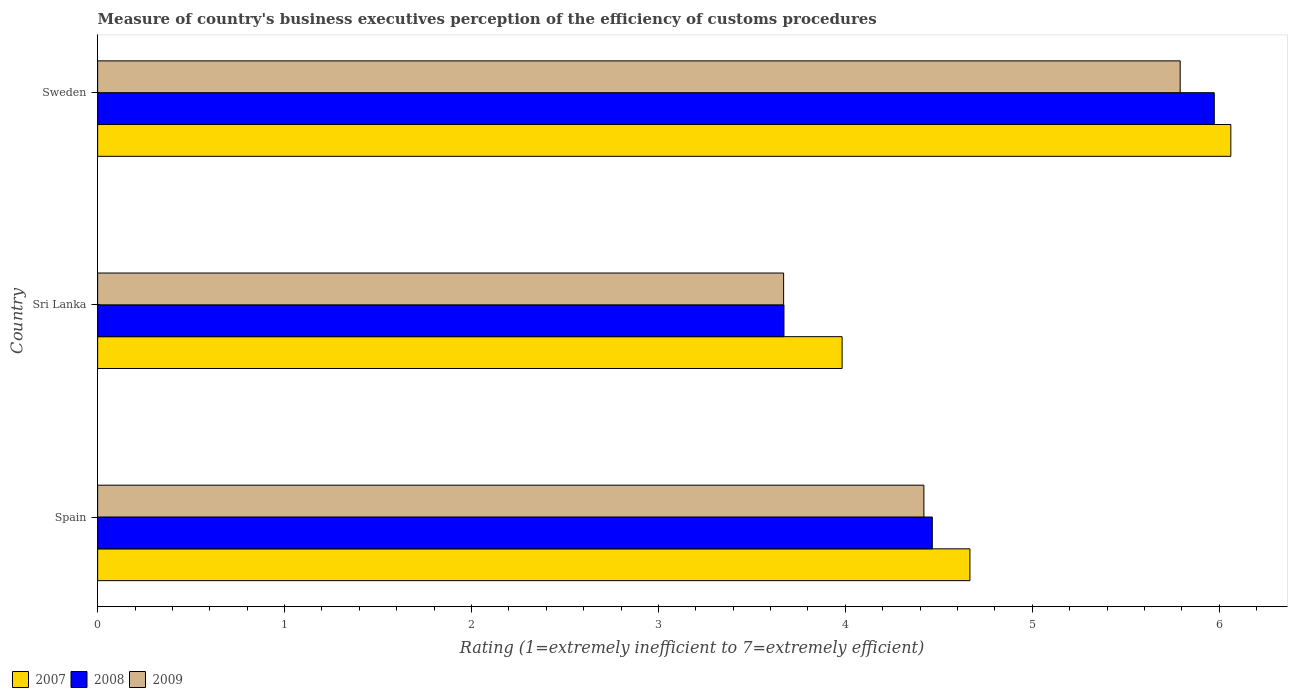Are the number of bars per tick equal to the number of legend labels?
Keep it short and to the point. Yes. Are the number of bars on each tick of the Y-axis equal?
Your answer should be compact. Yes. What is the label of the 3rd group of bars from the top?
Offer a very short reply. Spain. In how many cases, is the number of bars for a given country not equal to the number of legend labels?
Give a very brief answer. 0. What is the rating of the efficiency of customs procedure in 2008 in Spain?
Ensure brevity in your answer.  4.47. Across all countries, what is the maximum rating of the efficiency of customs procedure in 2007?
Give a very brief answer. 6.06. Across all countries, what is the minimum rating of the efficiency of customs procedure in 2008?
Keep it short and to the point. 3.67. In which country was the rating of the efficiency of customs procedure in 2007 minimum?
Ensure brevity in your answer.  Sri Lanka. What is the total rating of the efficiency of customs procedure in 2007 in the graph?
Give a very brief answer. 14.71. What is the difference between the rating of the efficiency of customs procedure in 2009 in Spain and that in Sri Lanka?
Provide a succinct answer. 0.75. What is the difference between the rating of the efficiency of customs procedure in 2008 in Spain and the rating of the efficiency of customs procedure in 2009 in Sweden?
Your response must be concise. -1.33. What is the average rating of the efficiency of customs procedure in 2009 per country?
Give a very brief answer. 4.63. What is the difference between the rating of the efficiency of customs procedure in 2007 and rating of the efficiency of customs procedure in 2008 in Sri Lanka?
Provide a succinct answer. 0.31. In how many countries, is the rating of the efficiency of customs procedure in 2009 greater than 0.8 ?
Your response must be concise. 3. What is the ratio of the rating of the efficiency of customs procedure in 2008 in Spain to that in Sweden?
Ensure brevity in your answer.  0.75. Is the rating of the efficiency of customs procedure in 2007 in Spain less than that in Sweden?
Keep it short and to the point. Yes. Is the difference between the rating of the efficiency of customs procedure in 2007 in Spain and Sweden greater than the difference between the rating of the efficiency of customs procedure in 2008 in Spain and Sweden?
Make the answer very short. Yes. What is the difference between the highest and the second highest rating of the efficiency of customs procedure in 2007?
Your answer should be very brief. 1.4. What is the difference between the highest and the lowest rating of the efficiency of customs procedure in 2007?
Provide a succinct answer. 2.08. In how many countries, is the rating of the efficiency of customs procedure in 2007 greater than the average rating of the efficiency of customs procedure in 2007 taken over all countries?
Provide a short and direct response. 1. Is the sum of the rating of the efficiency of customs procedure in 2007 in Spain and Sri Lanka greater than the maximum rating of the efficiency of customs procedure in 2008 across all countries?
Your answer should be very brief. Yes. How many countries are there in the graph?
Your answer should be compact. 3. Are the values on the major ticks of X-axis written in scientific E-notation?
Your response must be concise. No. Does the graph contain any zero values?
Your answer should be compact. No. Does the graph contain grids?
Your answer should be compact. No. Where does the legend appear in the graph?
Give a very brief answer. Bottom left. What is the title of the graph?
Keep it short and to the point. Measure of country's business executives perception of the efficiency of customs procedures. What is the label or title of the X-axis?
Give a very brief answer. Rating (1=extremely inefficient to 7=extremely efficient). What is the Rating (1=extremely inefficient to 7=extremely efficient) of 2007 in Spain?
Provide a succinct answer. 4.67. What is the Rating (1=extremely inefficient to 7=extremely efficient) of 2008 in Spain?
Your response must be concise. 4.47. What is the Rating (1=extremely inefficient to 7=extremely efficient) of 2009 in Spain?
Make the answer very short. 4.42. What is the Rating (1=extremely inefficient to 7=extremely efficient) in 2007 in Sri Lanka?
Keep it short and to the point. 3.98. What is the Rating (1=extremely inefficient to 7=extremely efficient) in 2008 in Sri Lanka?
Provide a short and direct response. 3.67. What is the Rating (1=extremely inefficient to 7=extremely efficient) of 2009 in Sri Lanka?
Provide a succinct answer. 3.67. What is the Rating (1=extremely inefficient to 7=extremely efficient) of 2007 in Sweden?
Your answer should be very brief. 6.06. What is the Rating (1=extremely inefficient to 7=extremely efficient) of 2008 in Sweden?
Give a very brief answer. 5.97. What is the Rating (1=extremely inefficient to 7=extremely efficient) in 2009 in Sweden?
Make the answer very short. 5.79. Across all countries, what is the maximum Rating (1=extremely inefficient to 7=extremely efficient) of 2007?
Provide a short and direct response. 6.06. Across all countries, what is the maximum Rating (1=extremely inefficient to 7=extremely efficient) of 2008?
Offer a terse response. 5.97. Across all countries, what is the maximum Rating (1=extremely inefficient to 7=extremely efficient) in 2009?
Your answer should be compact. 5.79. Across all countries, what is the minimum Rating (1=extremely inefficient to 7=extremely efficient) in 2007?
Offer a terse response. 3.98. Across all countries, what is the minimum Rating (1=extremely inefficient to 7=extremely efficient) of 2008?
Your response must be concise. 3.67. Across all countries, what is the minimum Rating (1=extremely inefficient to 7=extremely efficient) in 2009?
Give a very brief answer. 3.67. What is the total Rating (1=extremely inefficient to 7=extremely efficient) in 2007 in the graph?
Provide a succinct answer. 14.71. What is the total Rating (1=extremely inefficient to 7=extremely efficient) of 2008 in the graph?
Provide a short and direct response. 14.11. What is the total Rating (1=extremely inefficient to 7=extremely efficient) in 2009 in the graph?
Your answer should be very brief. 13.88. What is the difference between the Rating (1=extremely inefficient to 7=extremely efficient) in 2007 in Spain and that in Sri Lanka?
Your response must be concise. 0.68. What is the difference between the Rating (1=extremely inefficient to 7=extremely efficient) of 2008 in Spain and that in Sri Lanka?
Make the answer very short. 0.79. What is the difference between the Rating (1=extremely inefficient to 7=extremely efficient) in 2009 in Spain and that in Sri Lanka?
Ensure brevity in your answer.  0.75. What is the difference between the Rating (1=extremely inefficient to 7=extremely efficient) in 2007 in Spain and that in Sweden?
Give a very brief answer. -1.4. What is the difference between the Rating (1=extremely inefficient to 7=extremely efficient) of 2008 in Spain and that in Sweden?
Your answer should be very brief. -1.51. What is the difference between the Rating (1=extremely inefficient to 7=extremely efficient) of 2009 in Spain and that in Sweden?
Your response must be concise. -1.37. What is the difference between the Rating (1=extremely inefficient to 7=extremely efficient) in 2007 in Sri Lanka and that in Sweden?
Offer a very short reply. -2.08. What is the difference between the Rating (1=extremely inefficient to 7=extremely efficient) of 2008 in Sri Lanka and that in Sweden?
Provide a succinct answer. -2.3. What is the difference between the Rating (1=extremely inefficient to 7=extremely efficient) in 2009 in Sri Lanka and that in Sweden?
Offer a very short reply. -2.12. What is the difference between the Rating (1=extremely inefficient to 7=extremely efficient) in 2008 in Spain and the Rating (1=extremely inefficient to 7=extremely efficient) in 2009 in Sri Lanka?
Provide a short and direct response. 0.8. What is the difference between the Rating (1=extremely inefficient to 7=extremely efficient) in 2007 in Spain and the Rating (1=extremely inefficient to 7=extremely efficient) in 2008 in Sweden?
Keep it short and to the point. -1.31. What is the difference between the Rating (1=extremely inefficient to 7=extremely efficient) in 2007 in Spain and the Rating (1=extremely inefficient to 7=extremely efficient) in 2009 in Sweden?
Give a very brief answer. -1.12. What is the difference between the Rating (1=extremely inefficient to 7=extremely efficient) in 2008 in Spain and the Rating (1=extremely inefficient to 7=extremely efficient) in 2009 in Sweden?
Provide a succinct answer. -1.33. What is the difference between the Rating (1=extremely inefficient to 7=extremely efficient) in 2007 in Sri Lanka and the Rating (1=extremely inefficient to 7=extremely efficient) in 2008 in Sweden?
Give a very brief answer. -1.99. What is the difference between the Rating (1=extremely inefficient to 7=extremely efficient) in 2007 in Sri Lanka and the Rating (1=extremely inefficient to 7=extremely efficient) in 2009 in Sweden?
Provide a succinct answer. -1.81. What is the difference between the Rating (1=extremely inefficient to 7=extremely efficient) in 2008 in Sri Lanka and the Rating (1=extremely inefficient to 7=extremely efficient) in 2009 in Sweden?
Give a very brief answer. -2.12. What is the average Rating (1=extremely inefficient to 7=extremely efficient) of 2007 per country?
Keep it short and to the point. 4.9. What is the average Rating (1=extremely inefficient to 7=extremely efficient) of 2008 per country?
Make the answer very short. 4.7. What is the average Rating (1=extremely inefficient to 7=extremely efficient) in 2009 per country?
Make the answer very short. 4.63. What is the difference between the Rating (1=extremely inefficient to 7=extremely efficient) of 2007 and Rating (1=extremely inefficient to 7=extremely efficient) of 2008 in Spain?
Ensure brevity in your answer.  0.2. What is the difference between the Rating (1=extremely inefficient to 7=extremely efficient) of 2007 and Rating (1=extremely inefficient to 7=extremely efficient) of 2009 in Spain?
Your response must be concise. 0.25. What is the difference between the Rating (1=extremely inefficient to 7=extremely efficient) in 2008 and Rating (1=extremely inefficient to 7=extremely efficient) in 2009 in Spain?
Make the answer very short. 0.05. What is the difference between the Rating (1=extremely inefficient to 7=extremely efficient) of 2007 and Rating (1=extremely inefficient to 7=extremely efficient) of 2008 in Sri Lanka?
Provide a short and direct response. 0.31. What is the difference between the Rating (1=extremely inefficient to 7=extremely efficient) in 2007 and Rating (1=extremely inefficient to 7=extremely efficient) in 2009 in Sri Lanka?
Your answer should be very brief. 0.31. What is the difference between the Rating (1=extremely inefficient to 7=extremely efficient) in 2008 and Rating (1=extremely inefficient to 7=extremely efficient) in 2009 in Sri Lanka?
Offer a terse response. 0. What is the difference between the Rating (1=extremely inefficient to 7=extremely efficient) in 2007 and Rating (1=extremely inefficient to 7=extremely efficient) in 2008 in Sweden?
Provide a succinct answer. 0.09. What is the difference between the Rating (1=extremely inefficient to 7=extremely efficient) in 2007 and Rating (1=extremely inefficient to 7=extremely efficient) in 2009 in Sweden?
Keep it short and to the point. 0.27. What is the difference between the Rating (1=extremely inefficient to 7=extremely efficient) in 2008 and Rating (1=extremely inefficient to 7=extremely efficient) in 2009 in Sweden?
Offer a terse response. 0.18. What is the ratio of the Rating (1=extremely inefficient to 7=extremely efficient) of 2007 in Spain to that in Sri Lanka?
Give a very brief answer. 1.17. What is the ratio of the Rating (1=extremely inefficient to 7=extremely efficient) in 2008 in Spain to that in Sri Lanka?
Your answer should be compact. 1.22. What is the ratio of the Rating (1=extremely inefficient to 7=extremely efficient) of 2009 in Spain to that in Sri Lanka?
Provide a short and direct response. 1.2. What is the ratio of the Rating (1=extremely inefficient to 7=extremely efficient) in 2007 in Spain to that in Sweden?
Offer a terse response. 0.77. What is the ratio of the Rating (1=extremely inefficient to 7=extremely efficient) in 2008 in Spain to that in Sweden?
Keep it short and to the point. 0.75. What is the ratio of the Rating (1=extremely inefficient to 7=extremely efficient) in 2009 in Spain to that in Sweden?
Your answer should be very brief. 0.76. What is the ratio of the Rating (1=extremely inefficient to 7=extremely efficient) in 2007 in Sri Lanka to that in Sweden?
Make the answer very short. 0.66. What is the ratio of the Rating (1=extremely inefficient to 7=extremely efficient) in 2008 in Sri Lanka to that in Sweden?
Keep it short and to the point. 0.61. What is the ratio of the Rating (1=extremely inefficient to 7=extremely efficient) in 2009 in Sri Lanka to that in Sweden?
Make the answer very short. 0.63. What is the difference between the highest and the second highest Rating (1=extremely inefficient to 7=extremely efficient) in 2007?
Provide a short and direct response. 1.4. What is the difference between the highest and the second highest Rating (1=extremely inefficient to 7=extremely efficient) of 2008?
Make the answer very short. 1.51. What is the difference between the highest and the second highest Rating (1=extremely inefficient to 7=extremely efficient) in 2009?
Your answer should be very brief. 1.37. What is the difference between the highest and the lowest Rating (1=extremely inefficient to 7=extremely efficient) in 2007?
Provide a succinct answer. 2.08. What is the difference between the highest and the lowest Rating (1=extremely inefficient to 7=extremely efficient) of 2008?
Provide a succinct answer. 2.3. What is the difference between the highest and the lowest Rating (1=extremely inefficient to 7=extremely efficient) in 2009?
Ensure brevity in your answer.  2.12. 